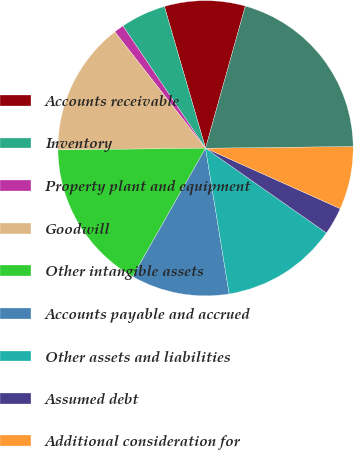<chart> <loc_0><loc_0><loc_500><loc_500><pie_chart><fcel>Accounts receivable<fcel>Inventory<fcel>Property plant and equipment<fcel>Goodwill<fcel>Other intangible assets<fcel>Accounts payable and accrued<fcel>Other assets and liabilities<fcel>Assumed debt<fcel>Additional consideration for<fcel>Net cash consideration<nl><fcel>8.84%<fcel>4.96%<fcel>1.08%<fcel>14.65%<fcel>16.59%<fcel>10.78%<fcel>12.71%<fcel>3.02%<fcel>6.9%<fcel>20.47%<nl></chart> 